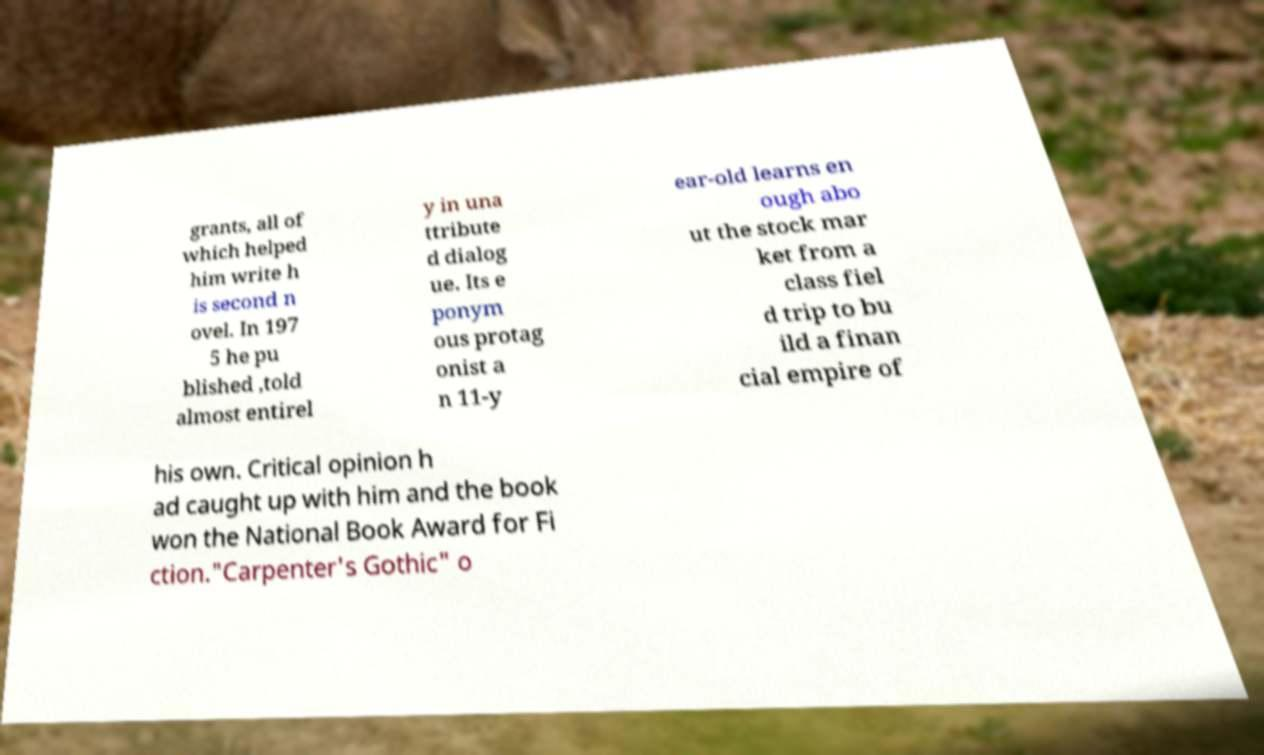For documentation purposes, I need the text within this image transcribed. Could you provide that? grants, all of which helped him write h is second n ovel. In 197 5 he pu blished ,told almost entirel y in una ttribute d dialog ue. Its e ponym ous protag onist a n 11-y ear-old learns en ough abo ut the stock mar ket from a class fiel d trip to bu ild a finan cial empire of his own. Critical opinion h ad caught up with him and the book won the National Book Award for Fi ction."Carpenter's Gothic" o 